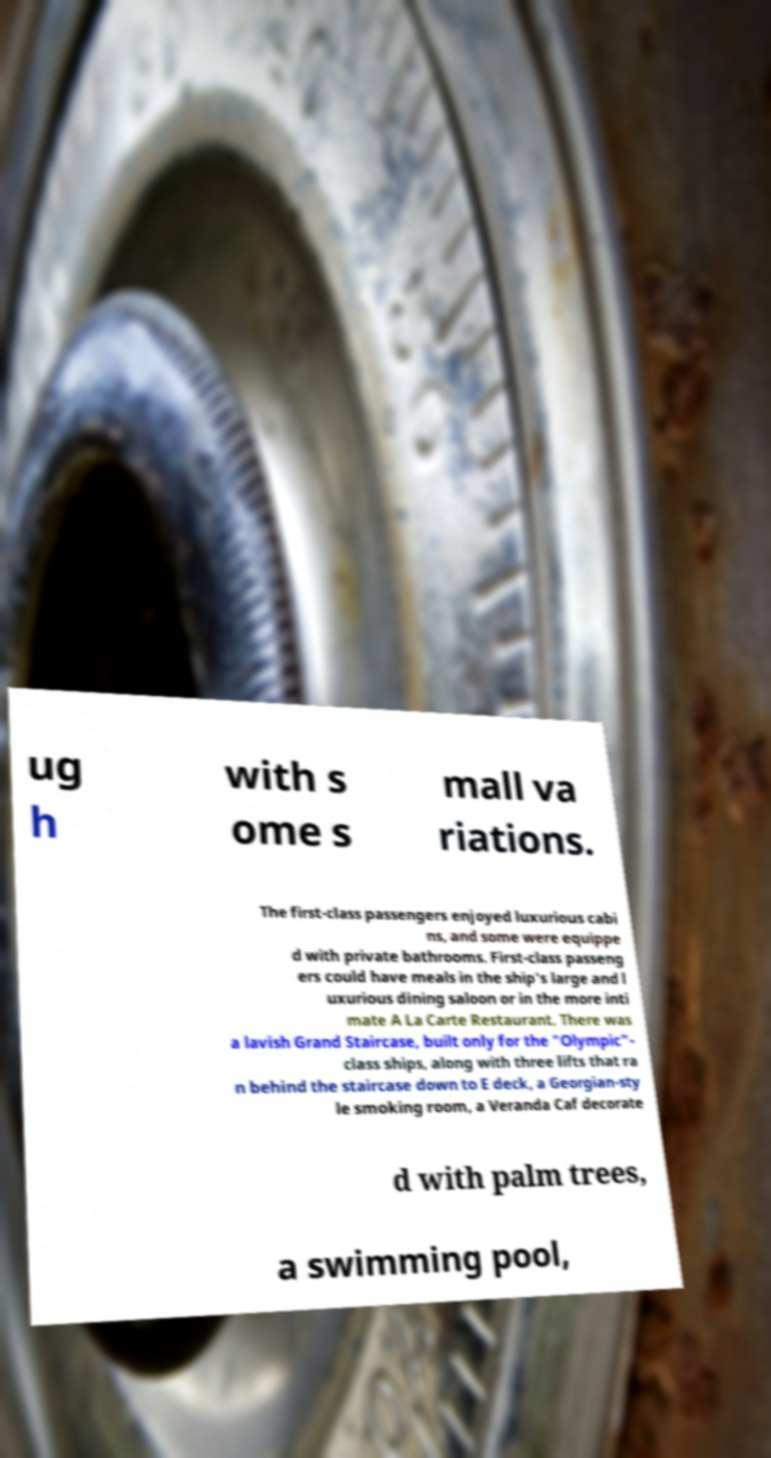For documentation purposes, I need the text within this image transcribed. Could you provide that? ug h with s ome s mall va riations. The first-class passengers enjoyed luxurious cabi ns, and some were equippe d with private bathrooms. First-class passeng ers could have meals in the ship's large and l uxurious dining saloon or in the more inti mate A La Carte Restaurant. There was a lavish Grand Staircase, built only for the "Olympic"- class ships, along with three lifts that ra n behind the staircase down to E deck, a Georgian-sty le smoking room, a Veranda Caf decorate d with palm trees, a swimming pool, 